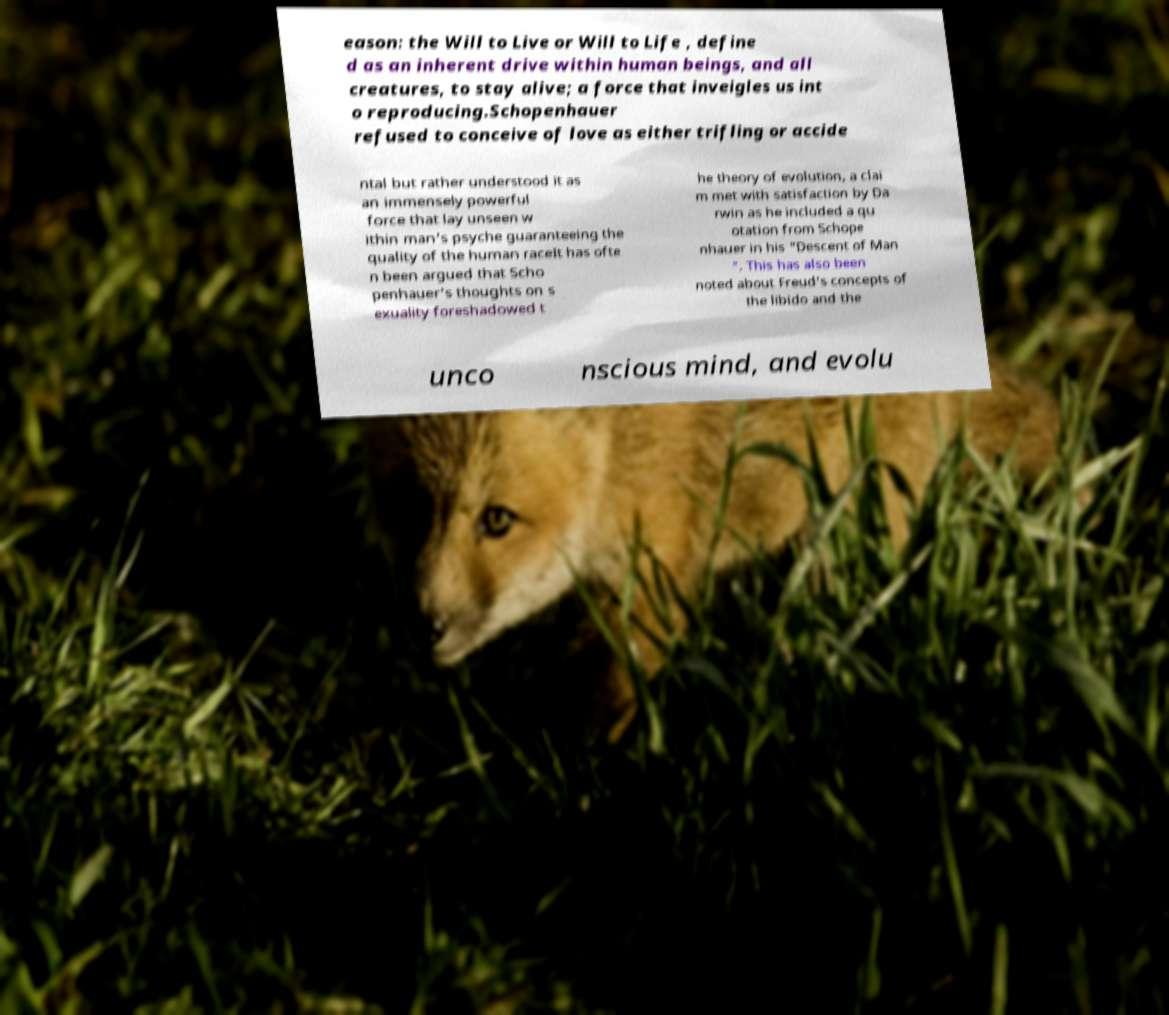Please read and relay the text visible in this image. What does it say? eason: the Will to Live or Will to Life , define d as an inherent drive within human beings, and all creatures, to stay alive; a force that inveigles us int o reproducing.Schopenhauer refused to conceive of love as either trifling or accide ntal but rather understood it as an immensely powerful force that lay unseen w ithin man's psyche guaranteeing the quality of the human raceIt has ofte n been argued that Scho penhauer's thoughts on s exuality foreshadowed t he theory of evolution, a clai m met with satisfaction by Da rwin as he included a qu otation from Schope nhauer in his "Descent of Man ". This has also been noted about Freud's concepts of the libido and the unco nscious mind, and evolu 